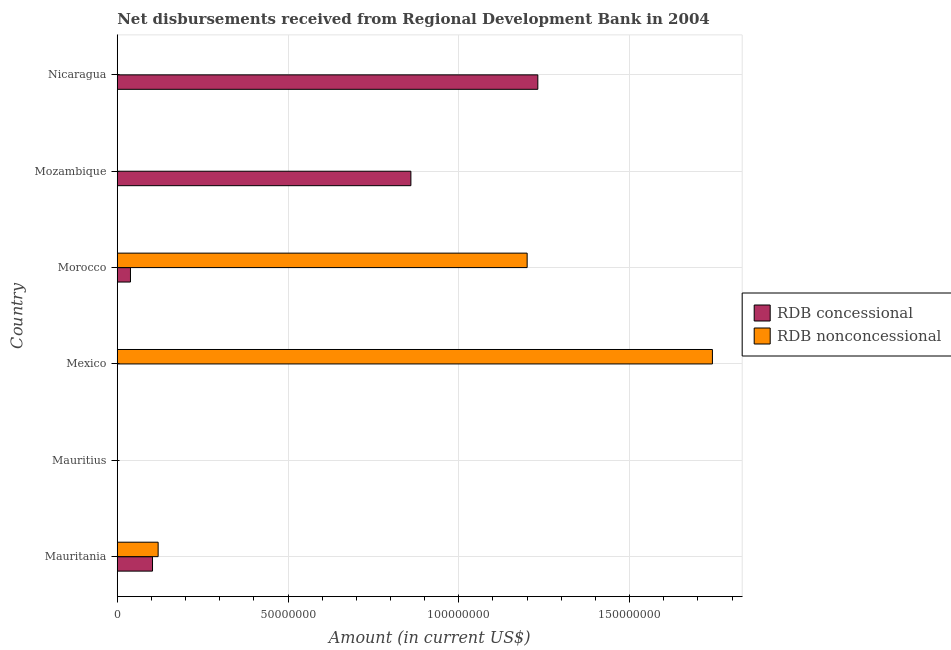Are the number of bars per tick equal to the number of legend labels?
Provide a short and direct response. No. How many bars are there on the 6th tick from the top?
Provide a succinct answer. 2. How many bars are there on the 1st tick from the bottom?
Offer a very short reply. 2. In how many cases, is the number of bars for a given country not equal to the number of legend labels?
Offer a terse response. 4. Across all countries, what is the maximum net non concessional disbursements from rdb?
Ensure brevity in your answer.  1.74e+08. Across all countries, what is the minimum net concessional disbursements from rdb?
Offer a very short reply. 0. In which country was the net concessional disbursements from rdb maximum?
Give a very brief answer. Nicaragua. What is the total net non concessional disbursements from rdb in the graph?
Offer a terse response. 3.06e+08. What is the difference between the net non concessional disbursements from rdb in Mexico and that in Morocco?
Provide a succinct answer. 5.42e+07. What is the difference between the net non concessional disbursements from rdb in Mozambique and the net concessional disbursements from rdb in Mauritania?
Your answer should be compact. -1.03e+07. What is the average net concessional disbursements from rdb per country?
Your answer should be compact. 3.72e+07. What is the difference between the net non concessional disbursements from rdb and net concessional disbursements from rdb in Morocco?
Your response must be concise. 1.16e+08. In how many countries, is the net non concessional disbursements from rdb greater than 40000000 US$?
Provide a short and direct response. 2. What is the ratio of the net concessional disbursements from rdb in Mauritania to that in Nicaragua?
Your response must be concise. 0.08. Is the net concessional disbursements from rdb in Mauritania less than that in Mozambique?
Offer a very short reply. Yes. Is the difference between the net concessional disbursements from rdb in Mauritania and Morocco greater than the difference between the net non concessional disbursements from rdb in Mauritania and Morocco?
Your answer should be compact. Yes. What is the difference between the highest and the second highest net concessional disbursements from rdb?
Provide a short and direct response. 3.72e+07. What is the difference between the highest and the lowest net concessional disbursements from rdb?
Offer a very short reply. 1.23e+08. In how many countries, is the net concessional disbursements from rdb greater than the average net concessional disbursements from rdb taken over all countries?
Offer a very short reply. 2. How many bars are there?
Ensure brevity in your answer.  7. Does the graph contain any zero values?
Your answer should be very brief. Yes. Does the graph contain grids?
Ensure brevity in your answer.  Yes. Where does the legend appear in the graph?
Offer a very short reply. Center right. How are the legend labels stacked?
Your response must be concise. Vertical. What is the title of the graph?
Provide a succinct answer. Net disbursements received from Regional Development Bank in 2004. Does "International Tourists" appear as one of the legend labels in the graph?
Your answer should be compact. No. What is the label or title of the X-axis?
Ensure brevity in your answer.  Amount (in current US$). What is the Amount (in current US$) of RDB concessional in Mauritania?
Your answer should be very brief. 1.03e+07. What is the Amount (in current US$) of RDB nonconcessional in Mauritania?
Your response must be concise. 1.20e+07. What is the Amount (in current US$) of RDB concessional in Mauritius?
Offer a terse response. 0. What is the Amount (in current US$) in RDB nonconcessional in Mexico?
Offer a terse response. 1.74e+08. What is the Amount (in current US$) in RDB concessional in Morocco?
Make the answer very short. 3.86e+06. What is the Amount (in current US$) of RDB nonconcessional in Morocco?
Make the answer very short. 1.20e+08. What is the Amount (in current US$) of RDB concessional in Mozambique?
Keep it short and to the point. 8.60e+07. What is the Amount (in current US$) in RDB concessional in Nicaragua?
Your answer should be compact. 1.23e+08. Across all countries, what is the maximum Amount (in current US$) of RDB concessional?
Your answer should be compact. 1.23e+08. Across all countries, what is the maximum Amount (in current US$) of RDB nonconcessional?
Keep it short and to the point. 1.74e+08. What is the total Amount (in current US$) of RDB concessional in the graph?
Offer a very short reply. 2.23e+08. What is the total Amount (in current US$) of RDB nonconcessional in the graph?
Give a very brief answer. 3.06e+08. What is the difference between the Amount (in current US$) of RDB nonconcessional in Mauritania and that in Mexico?
Keep it short and to the point. -1.62e+08. What is the difference between the Amount (in current US$) in RDB concessional in Mauritania and that in Morocco?
Provide a short and direct response. 6.46e+06. What is the difference between the Amount (in current US$) of RDB nonconcessional in Mauritania and that in Morocco?
Keep it short and to the point. -1.08e+08. What is the difference between the Amount (in current US$) of RDB concessional in Mauritania and that in Mozambique?
Provide a succinct answer. -7.57e+07. What is the difference between the Amount (in current US$) in RDB concessional in Mauritania and that in Nicaragua?
Your response must be concise. -1.13e+08. What is the difference between the Amount (in current US$) in RDB nonconcessional in Mexico and that in Morocco?
Your answer should be compact. 5.42e+07. What is the difference between the Amount (in current US$) of RDB concessional in Morocco and that in Mozambique?
Give a very brief answer. -8.21e+07. What is the difference between the Amount (in current US$) in RDB concessional in Morocco and that in Nicaragua?
Make the answer very short. -1.19e+08. What is the difference between the Amount (in current US$) in RDB concessional in Mozambique and that in Nicaragua?
Give a very brief answer. -3.72e+07. What is the difference between the Amount (in current US$) of RDB concessional in Mauritania and the Amount (in current US$) of RDB nonconcessional in Mexico?
Offer a terse response. -1.64e+08. What is the difference between the Amount (in current US$) in RDB concessional in Mauritania and the Amount (in current US$) in RDB nonconcessional in Morocco?
Give a very brief answer. -1.10e+08. What is the average Amount (in current US$) of RDB concessional per country?
Offer a very short reply. 3.72e+07. What is the average Amount (in current US$) of RDB nonconcessional per country?
Provide a succinct answer. 5.10e+07. What is the difference between the Amount (in current US$) of RDB concessional and Amount (in current US$) of RDB nonconcessional in Mauritania?
Your response must be concise. -1.65e+06. What is the difference between the Amount (in current US$) of RDB concessional and Amount (in current US$) of RDB nonconcessional in Morocco?
Provide a short and direct response. -1.16e+08. What is the ratio of the Amount (in current US$) in RDB nonconcessional in Mauritania to that in Mexico?
Your answer should be compact. 0.07. What is the ratio of the Amount (in current US$) in RDB concessional in Mauritania to that in Morocco?
Your response must be concise. 2.67. What is the ratio of the Amount (in current US$) of RDB nonconcessional in Mauritania to that in Morocco?
Make the answer very short. 0.1. What is the ratio of the Amount (in current US$) of RDB concessional in Mauritania to that in Mozambique?
Your answer should be compact. 0.12. What is the ratio of the Amount (in current US$) in RDB concessional in Mauritania to that in Nicaragua?
Keep it short and to the point. 0.08. What is the ratio of the Amount (in current US$) in RDB nonconcessional in Mexico to that in Morocco?
Keep it short and to the point. 1.45. What is the ratio of the Amount (in current US$) of RDB concessional in Morocco to that in Mozambique?
Provide a short and direct response. 0.04. What is the ratio of the Amount (in current US$) in RDB concessional in Morocco to that in Nicaragua?
Offer a terse response. 0.03. What is the ratio of the Amount (in current US$) of RDB concessional in Mozambique to that in Nicaragua?
Your answer should be very brief. 0.7. What is the difference between the highest and the second highest Amount (in current US$) in RDB concessional?
Provide a succinct answer. 3.72e+07. What is the difference between the highest and the second highest Amount (in current US$) in RDB nonconcessional?
Offer a terse response. 5.42e+07. What is the difference between the highest and the lowest Amount (in current US$) in RDB concessional?
Offer a terse response. 1.23e+08. What is the difference between the highest and the lowest Amount (in current US$) in RDB nonconcessional?
Your response must be concise. 1.74e+08. 